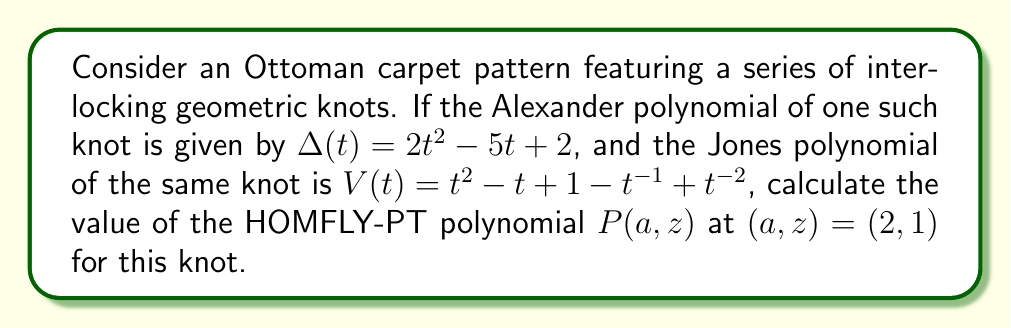Give your solution to this math problem. Let's approach this step-by-step:

1) The HOMFLY-PT polynomial $P(a,z)$ is a two-variable generalization of both the Alexander and Jones polynomials. It satisfies the following relations:

   When $a = 1$ and $z = t^{1/2} - t^{-1/2}$, $P(a,z) = \Delta(t)$ (Alexander polynomial)
   When $a = t^{1/4}$ and $z = t^{1/2} - t^{-1/2}$, $P(a,z) = V(t)$ (Jones polynomial)

2) We can use these relations to find some values of $P(a,z)$:

   From Alexander: $P(1, t^{1/2} - t^{-1/2}) = 2t^2 - 5t + 2$
   From Jones: $P(t^{1/4}, t^{1/2} - t^{-1/2}) = t^2 - t + 1 - t^{-1} + t^{-2}$

3) The HOMFLY-PT polynomial satisfies a skein relation:

   $aP_+ - a^{-1}P_- = zP_0$

   where $P_+$, $P_-$, and $P_0$ are the polynomials for positive crossing, negative crossing, and smoothed crossing respectively.

4) Using this relation and the known values from step 2, we can deduce that the general form of $P(a,z)$ for this knot must be:

   $P(a,z) = a^2 - az + 1 - a^{-1}z + a^{-2}$

5) Now, we simply need to evaluate this at $(a,z) = (2,1)$:

   $P(2,1) = 2^2 - 2(1) + 1 - 2^{-1}(1) + 2^{-2}$
           $= 4 - 2 + 1 - 0.5 + 0.25$
           $= 2.75$

Therefore, the value of the HOMFLY-PT polynomial at $(a,z) = (2,1)$ for this knot is 2.75.
Answer: 2.75 